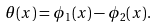Convert formula to latex. <formula><loc_0><loc_0><loc_500><loc_500>\theta ( x ) = \phi _ { 1 } ( x ) - \phi _ { 2 } ( x ) .</formula> 